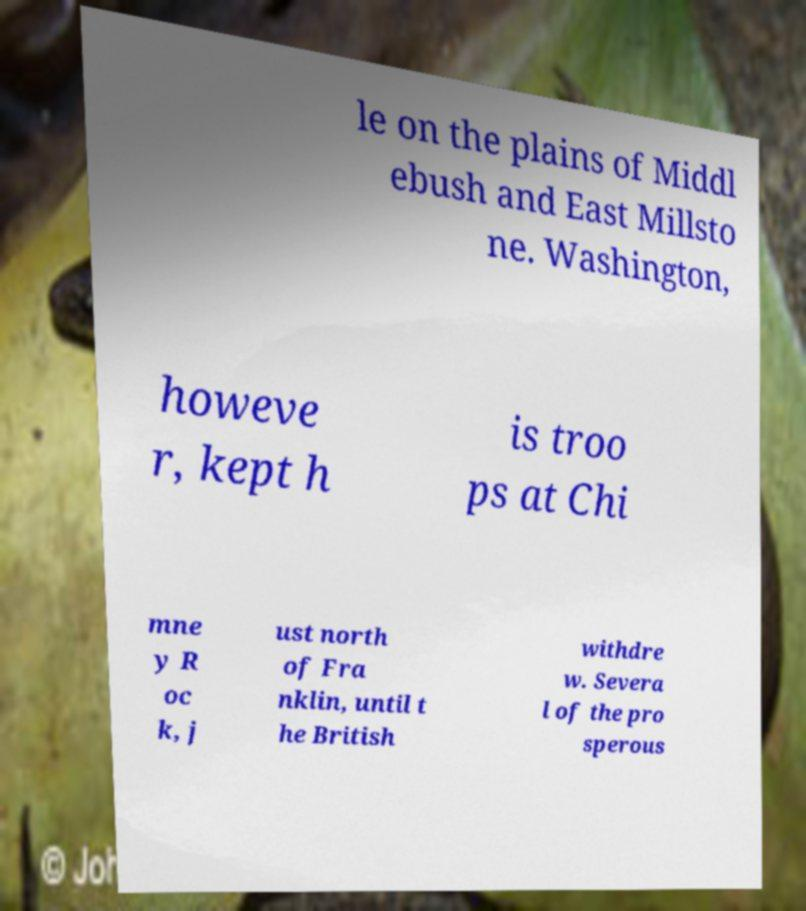I need the written content from this picture converted into text. Can you do that? le on the plains of Middl ebush and East Millsto ne. Washington, howeve r, kept h is troo ps at Chi mne y R oc k, j ust north of Fra nklin, until t he British withdre w. Severa l of the pro sperous 